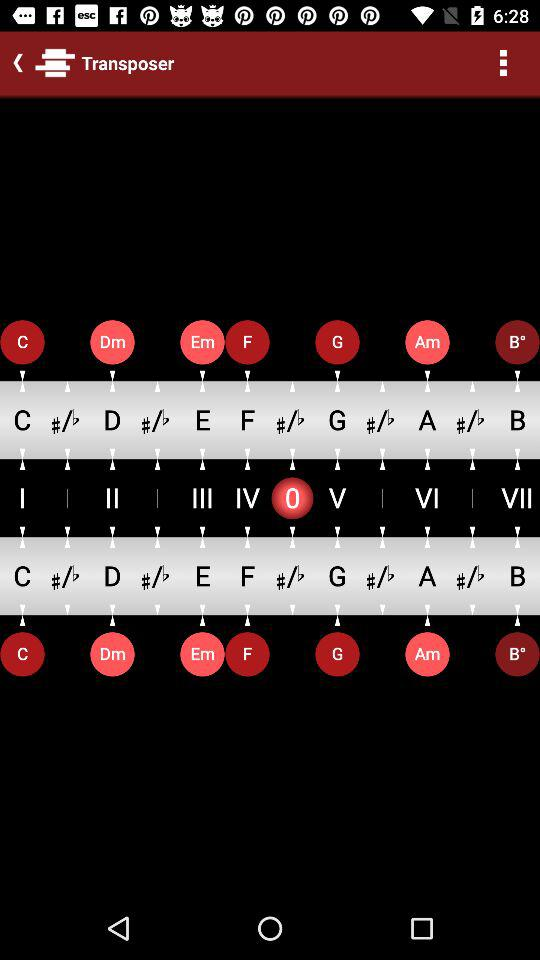How many more musical notes are there in the text at the top of the screen than in the text at the bottom of the screen?
Answer the question using a single word or phrase. 0 